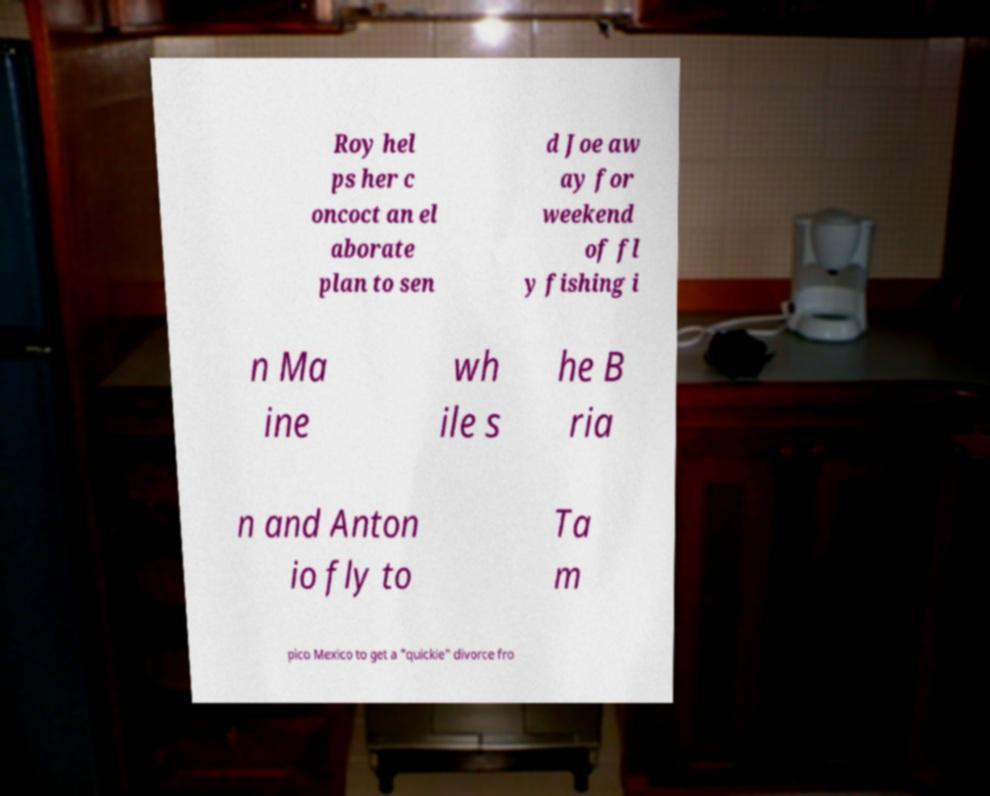Can you accurately transcribe the text from the provided image for me? Roy hel ps her c oncoct an el aborate plan to sen d Joe aw ay for weekend of fl y fishing i n Ma ine wh ile s he B ria n and Anton io fly to Ta m pico Mexico to get a "quickie" divorce fro 